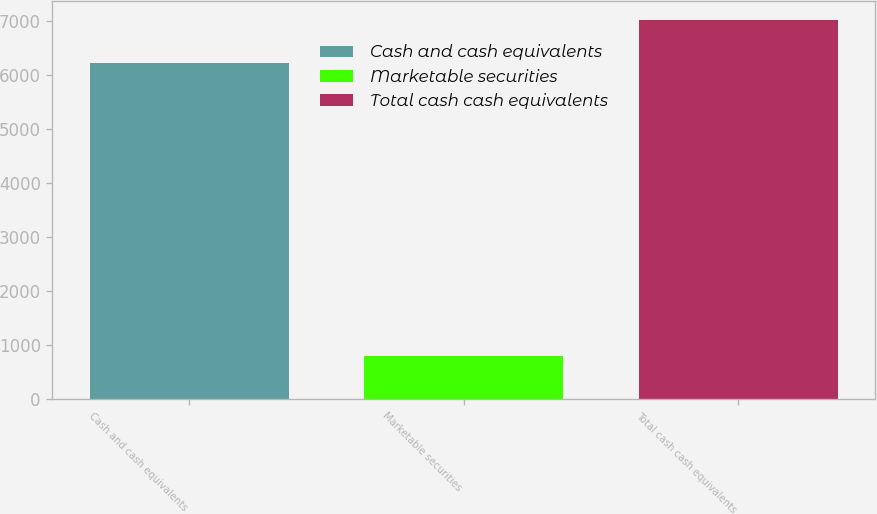<chart> <loc_0><loc_0><loc_500><loc_500><bar_chart><fcel>Cash and cash equivalents<fcel>Marketable securities<fcel>Total cash cash equivalents<nl><fcel>6218<fcel>802<fcel>7020<nl></chart> 